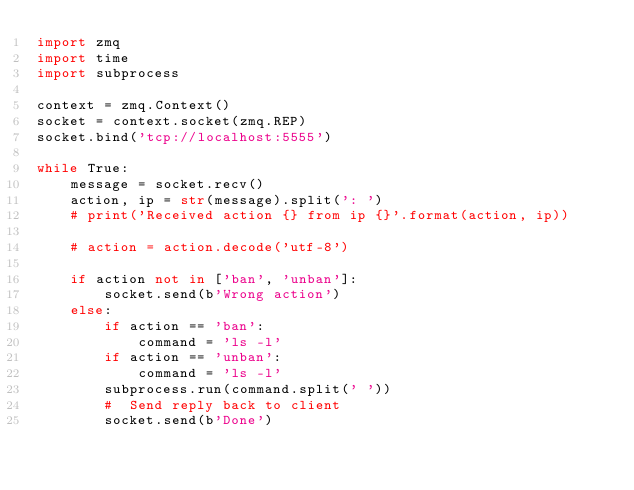<code> <loc_0><loc_0><loc_500><loc_500><_Python_>import zmq
import time
import subprocess

context = zmq.Context()
socket = context.socket(zmq.REP)
socket.bind('tcp://localhost:5555')

while True:
    message = socket.recv()
    action, ip = str(message).split(': ')
    # print('Received action {} from ip {}'.format(action, ip))

    # action = action.decode('utf-8')

    if action not in ['ban', 'unban']:
        socket.send(b'Wrong action')
    else:
        if action == 'ban':
            command = 'ls -l'
        if action == 'unban':
            command = 'ls -l'
        subprocess.run(command.split(' '))
        #  Send reply back to client
        socket.send(b'Done')
</code> 